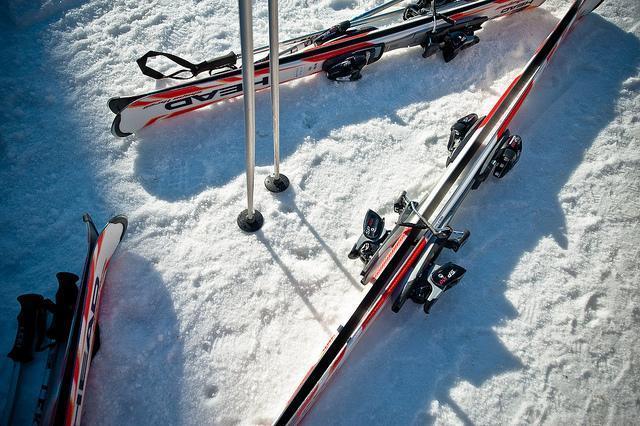How many ski can you see?
Give a very brief answer. 3. How many people are wearing blue helmets?
Give a very brief answer. 0. 